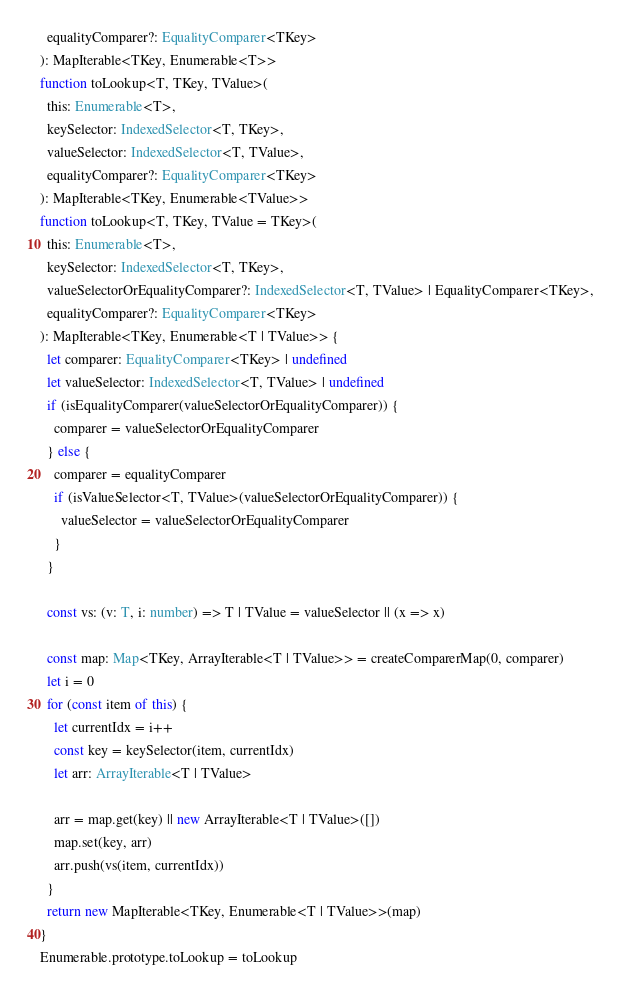<code> <loc_0><loc_0><loc_500><loc_500><_TypeScript_>  equalityComparer?: EqualityComparer<TKey>
): MapIterable<TKey, Enumerable<T>>
function toLookup<T, TKey, TValue>(
  this: Enumerable<T>,
  keySelector: IndexedSelector<T, TKey>,
  valueSelector: IndexedSelector<T, TValue>,
  equalityComparer?: EqualityComparer<TKey>
): MapIterable<TKey, Enumerable<TValue>>
function toLookup<T, TKey, TValue = TKey>(
  this: Enumerable<T>,
  keySelector: IndexedSelector<T, TKey>,
  valueSelectorOrEqualityComparer?: IndexedSelector<T, TValue> | EqualityComparer<TKey>,
  equalityComparer?: EqualityComparer<TKey>
): MapIterable<TKey, Enumerable<T | TValue>> {
  let comparer: EqualityComparer<TKey> | undefined
  let valueSelector: IndexedSelector<T, TValue> | undefined
  if (isEqualityComparer(valueSelectorOrEqualityComparer)) {
    comparer = valueSelectorOrEqualityComparer
  } else {
    comparer = equalityComparer
    if (isValueSelector<T, TValue>(valueSelectorOrEqualityComparer)) {
      valueSelector = valueSelectorOrEqualityComparer
    }
  }

  const vs: (v: T, i: number) => T | TValue = valueSelector || (x => x)

  const map: Map<TKey, ArrayIterable<T | TValue>> = createComparerMap(0, comparer)
  let i = 0
  for (const item of this) {
    let currentIdx = i++
    const key = keySelector(item, currentIdx)
    let arr: ArrayIterable<T | TValue>

    arr = map.get(key) || new ArrayIterable<T | TValue>([])
    map.set(key, arr)
    arr.push(vs(item, currentIdx))
  }
  return new MapIterable<TKey, Enumerable<T | TValue>>(map)
}
Enumerable.prototype.toLookup = toLookup
</code> 